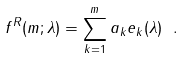<formula> <loc_0><loc_0><loc_500><loc_500>f ^ { R } ( m ; \lambda ) = \sum _ { k = 1 } ^ { m } a _ { k } e _ { k } ( \lambda ) \ .</formula> 